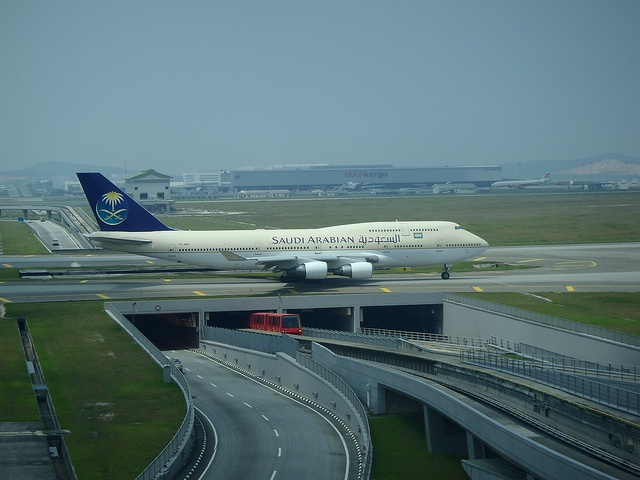Describe the objects in this image and their specific colors. I can see airplane in gray, beige, darkgray, and navy tones, bus in gray, black, maroon, and brown tones, airplane in gray and darkgray tones, airplane in gray, teal, and blue tones, and car in gray, purple, and black tones in this image. 